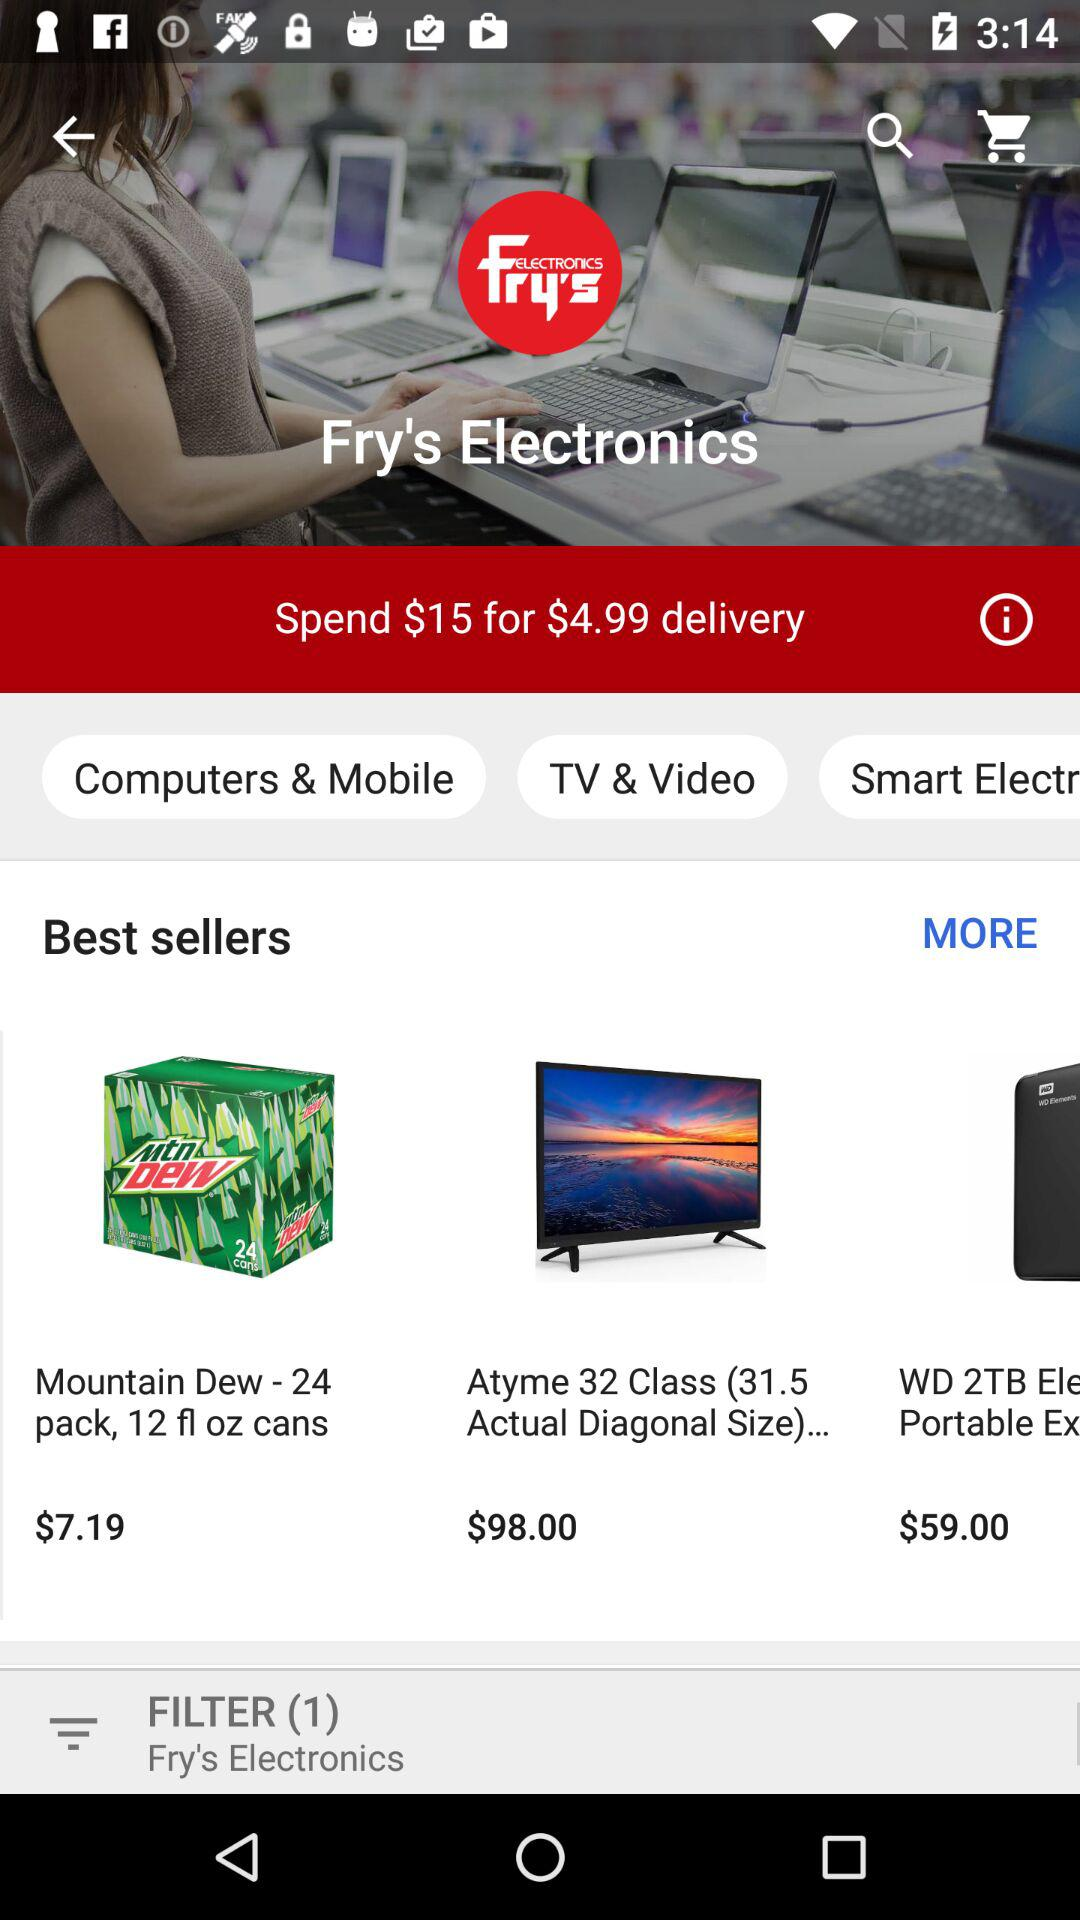How many filters are selected? There is one filter. 